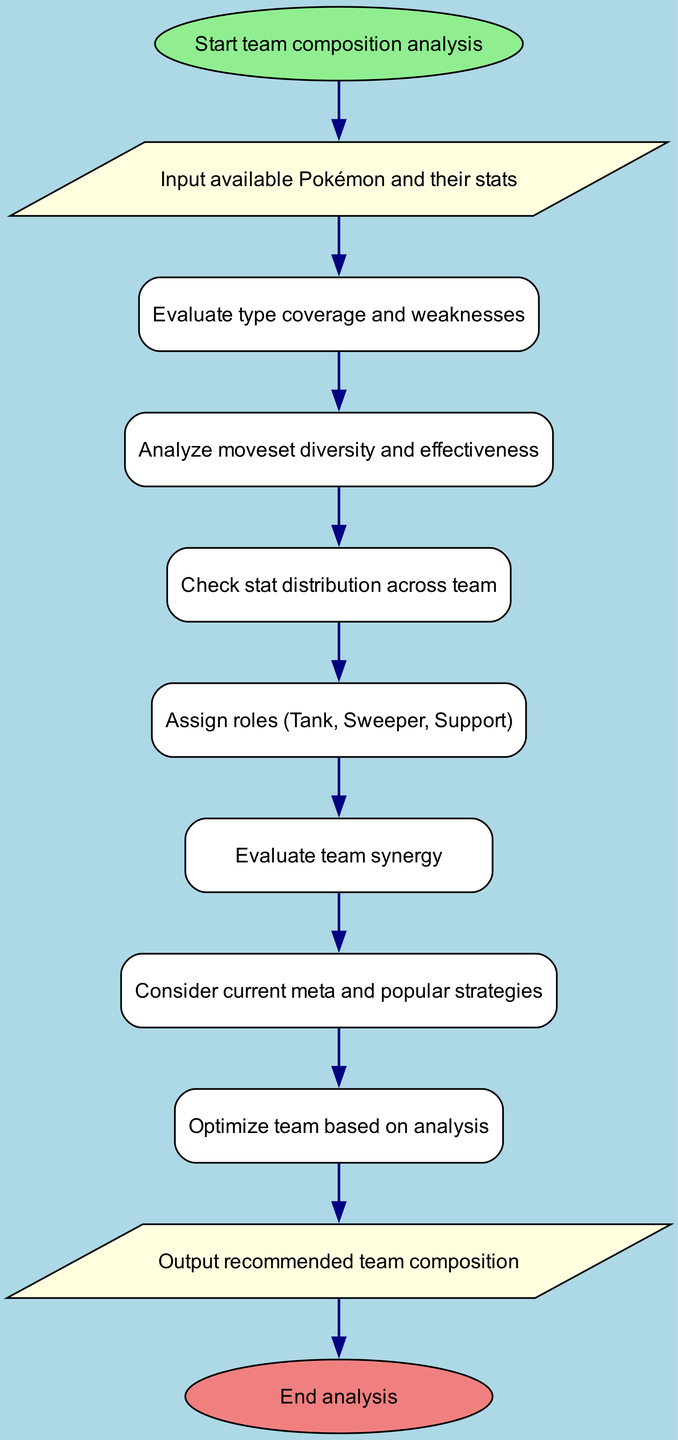What is the first step in the analysis? The first node in the diagram is labeled "Start team composition analysis," indicating the initial step.
Answer: Start team composition analysis How many nodes are present in the diagram? By counting the nodes listed in the data, there are a total of 11 nodes in the diagram.
Answer: 11 What evaluation is done after checking the moveset? The next step after "Analyze moveset diversity and effectiveness" is "Check stat distribution across team."
Answer: Check stat distribution across team What is the last step in the flowchart? The last node in the sequence is labeled "End analysis," which signifies the conclusion of the process.
Answer: End analysis Which node comes after evaluating team synergy? Following "Evaluate team synergy," the subsequent node is "Consider current meta and popular strategies."
Answer: Consider current meta and popular strategies What type of node is used to represent input in the diagram? The node representing input is categorized as a "parallelogram," which is a distinctive geometric shape for input/output processes.
Answer: Parallelogram How is team optimization performed in this analysis? "Optimize team based on analysis" implies that the previous steps inform adjustments to improve team composition, but the specifics of the optimization aren't detailed in the diagram.
Answer: Optimize team based on analysis Which role is likely assigned after checking stat distribution? The analysis progresses to "Assign roles (Tank, Sweeper, Support)" indicating that roles are determined subsequent to stats evaluation.
Answer: Assign roles (Tank, Sweeper, Support) 